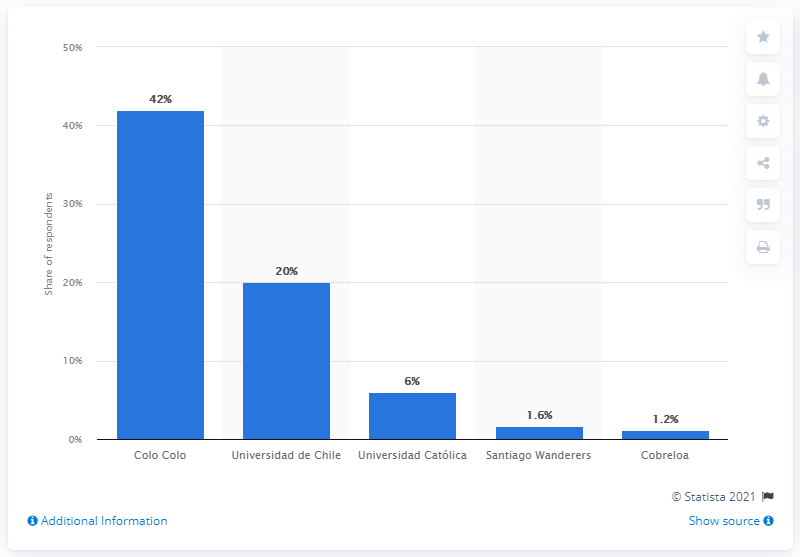Specify some key components in this picture. According to the survey, 20% of the respondents said that they like Universidad de Chile soccer team the most. 